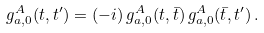<formula> <loc_0><loc_0><loc_500><loc_500>g _ { a , 0 } ^ { A } ( t , t ^ { \prime } ) = ( - i ) \, g _ { a , 0 } ^ { A } ( t , { \bar { t } } ) \, g _ { a , 0 } ^ { A } ( { \bar { t } } , t ^ { \prime } ) \, .</formula> 